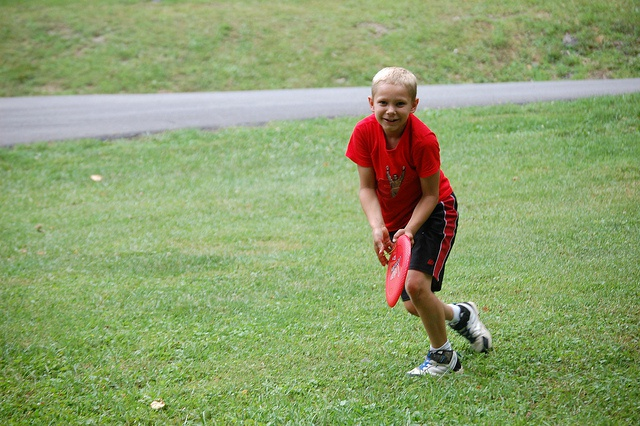Describe the objects in this image and their specific colors. I can see people in green, maroon, black, and gray tones and frisbee in green, salmon, lightpink, and red tones in this image. 